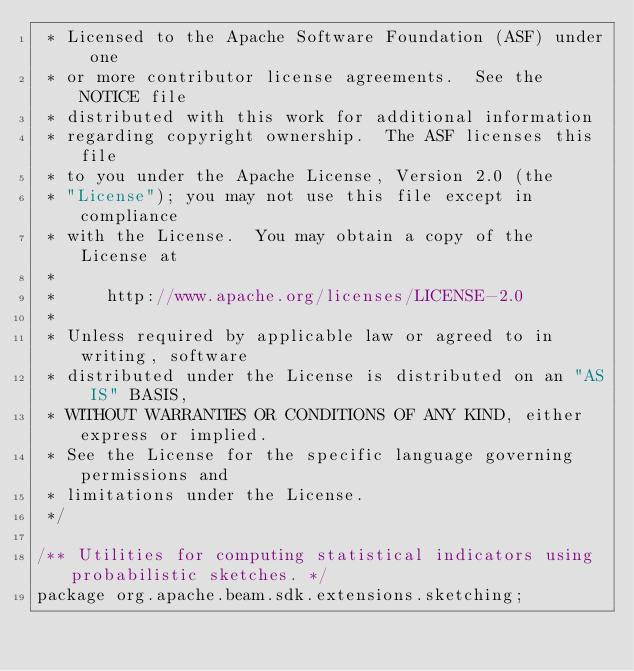Convert code to text. <code><loc_0><loc_0><loc_500><loc_500><_Java_> * Licensed to the Apache Software Foundation (ASF) under one
 * or more contributor license agreements.  See the NOTICE file
 * distributed with this work for additional information
 * regarding copyright ownership.  The ASF licenses this file
 * to you under the Apache License, Version 2.0 (the
 * "License"); you may not use this file except in compliance
 * with the License.  You may obtain a copy of the License at
 *
 *     http://www.apache.org/licenses/LICENSE-2.0
 *
 * Unless required by applicable law or agreed to in writing, software
 * distributed under the License is distributed on an "AS IS" BASIS,
 * WITHOUT WARRANTIES OR CONDITIONS OF ANY KIND, either express or implied.
 * See the License for the specific language governing permissions and
 * limitations under the License.
 */

/** Utilities for computing statistical indicators using probabilistic sketches. */
package org.apache.beam.sdk.extensions.sketching;
</code> 